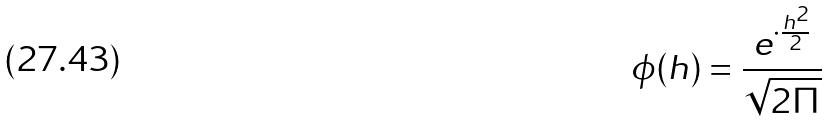Convert formula to latex. <formula><loc_0><loc_0><loc_500><loc_500>\phi ( h ) = \frac { e ^ { \cdot \frac { h ^ { 2 } } { 2 } } } { \sqrt { 2 \Pi } }</formula> 